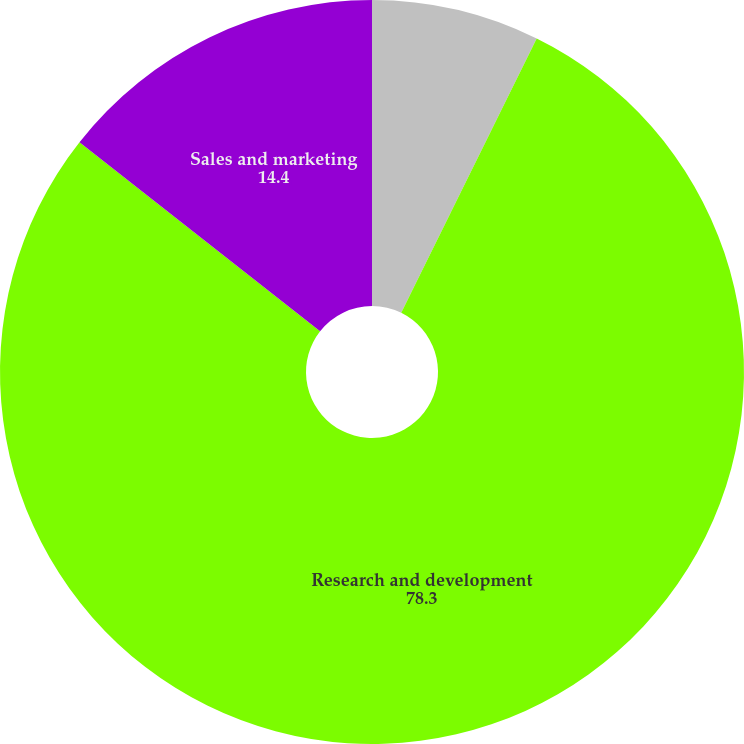<chart> <loc_0><loc_0><loc_500><loc_500><pie_chart><fcel>Cost of revenue<fcel>Research and development<fcel>Sales and marketing<nl><fcel>7.3%<fcel>78.3%<fcel>14.4%<nl></chart> 